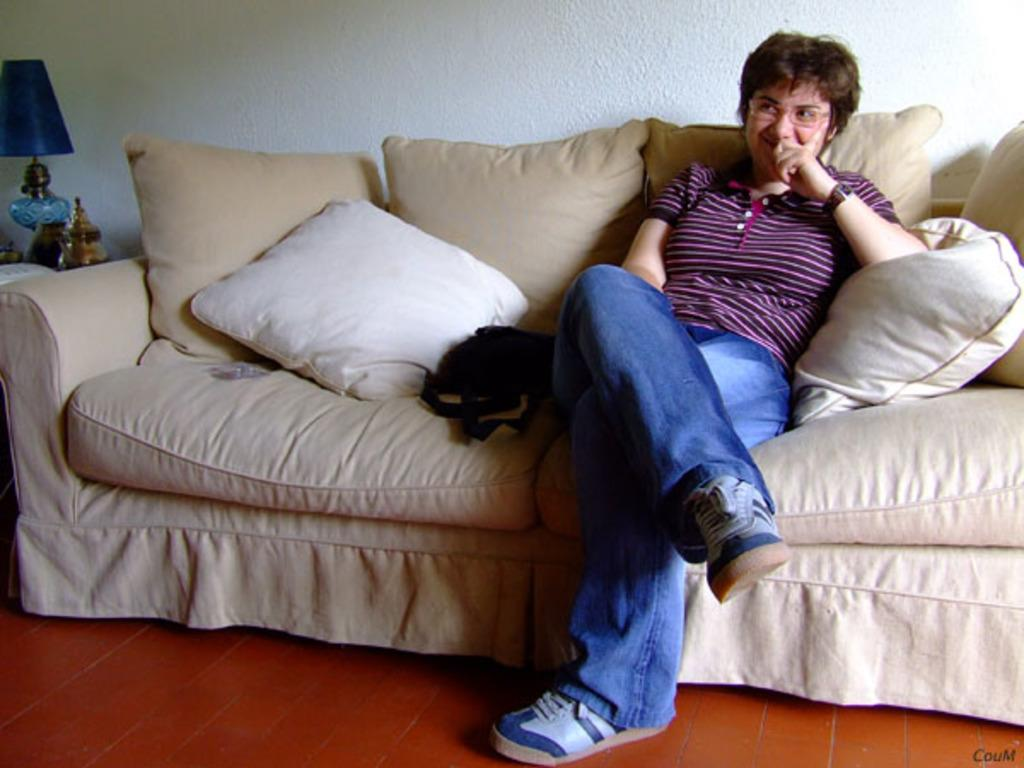What is the woman doing in the image? The woman is sitting on a sofa. What can be seen on the sofa? The sofa has two pillows. What is visible in the background of the image? There is a wall in the background. What can be seen on the left side of the image? There is a lamp on the left side of the image. What religion does the woman practice, as indicated by the image? There is no information about the woman's religion in the image. How many units of measurement can be seen in the image? There are no units of measurement present in the image. 